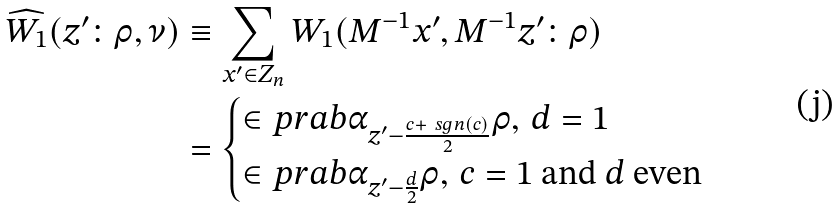<formula> <loc_0><loc_0><loc_500><loc_500>\widehat { W _ { 1 } } ( z ^ { \prime } \colon \rho , \nu ) & \equiv \sum _ { x ^ { \prime } \in Z _ { n } } W _ { 1 } ( M ^ { - 1 } x ^ { \prime } , M ^ { - 1 } z ^ { \prime } \colon \rho ) \\ & = \begin{cases} \in p r a b { \alpha _ { z ^ { \prime } - \frac { c + \ s g n ( c ) } { 2 } } } { \rho } , \, d = 1 \\ \in p r a b { \alpha _ { z ^ { \prime } - \frac { d } { 2 } } } { \rho } , \, c = 1 \text { and } d \text { even} \end{cases} \\</formula> 